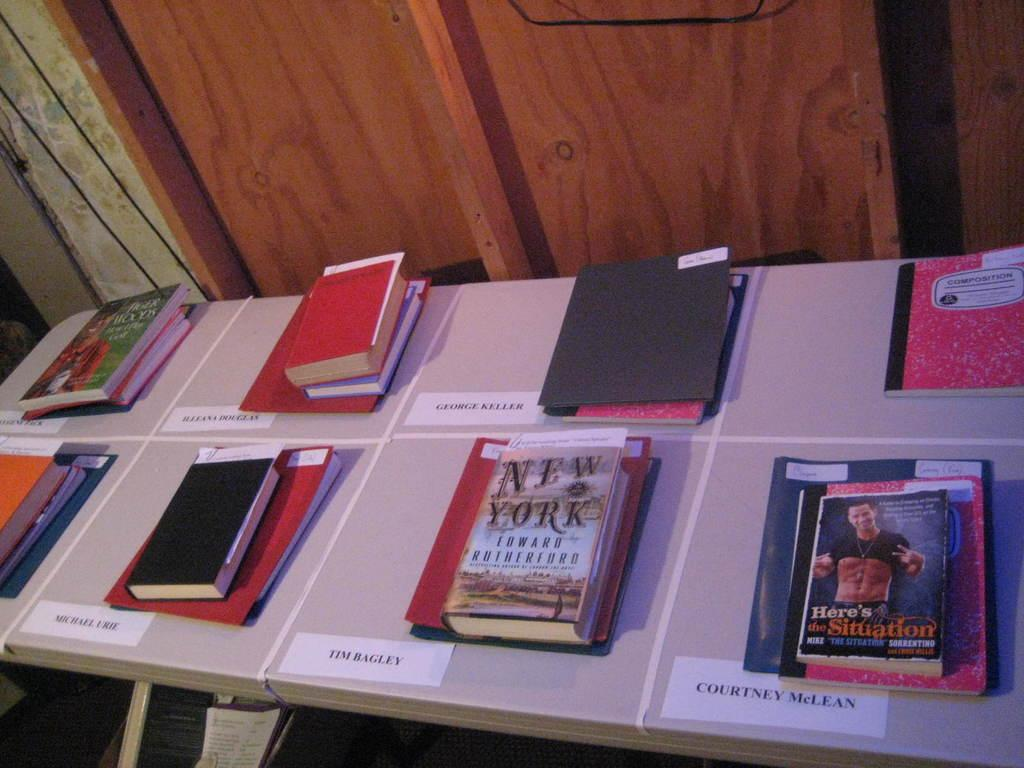<image>
Describe the image concisely. a desk with books on it with one of them titled 'new york' 